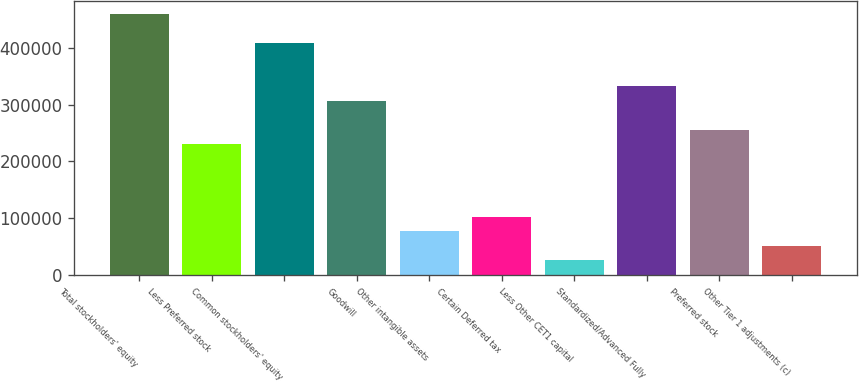<chart> <loc_0><loc_0><loc_500><loc_500><bar_chart><fcel>Total stockholders' equity<fcel>Less Preferred stock<fcel>Common stockholders' equity<fcel>Goodwill<fcel>Other intangible assets<fcel>Certain Deferred tax<fcel>Less Other CET1 capital<fcel>Standardized/Advanced Fully<fcel>Preferred stock<fcel>Other Tier 1 adjustments (c)<nl><fcel>460165<fcel>230134<fcel>409047<fcel>306811<fcel>76780<fcel>102339<fcel>25662<fcel>332370<fcel>255693<fcel>51221<nl></chart> 